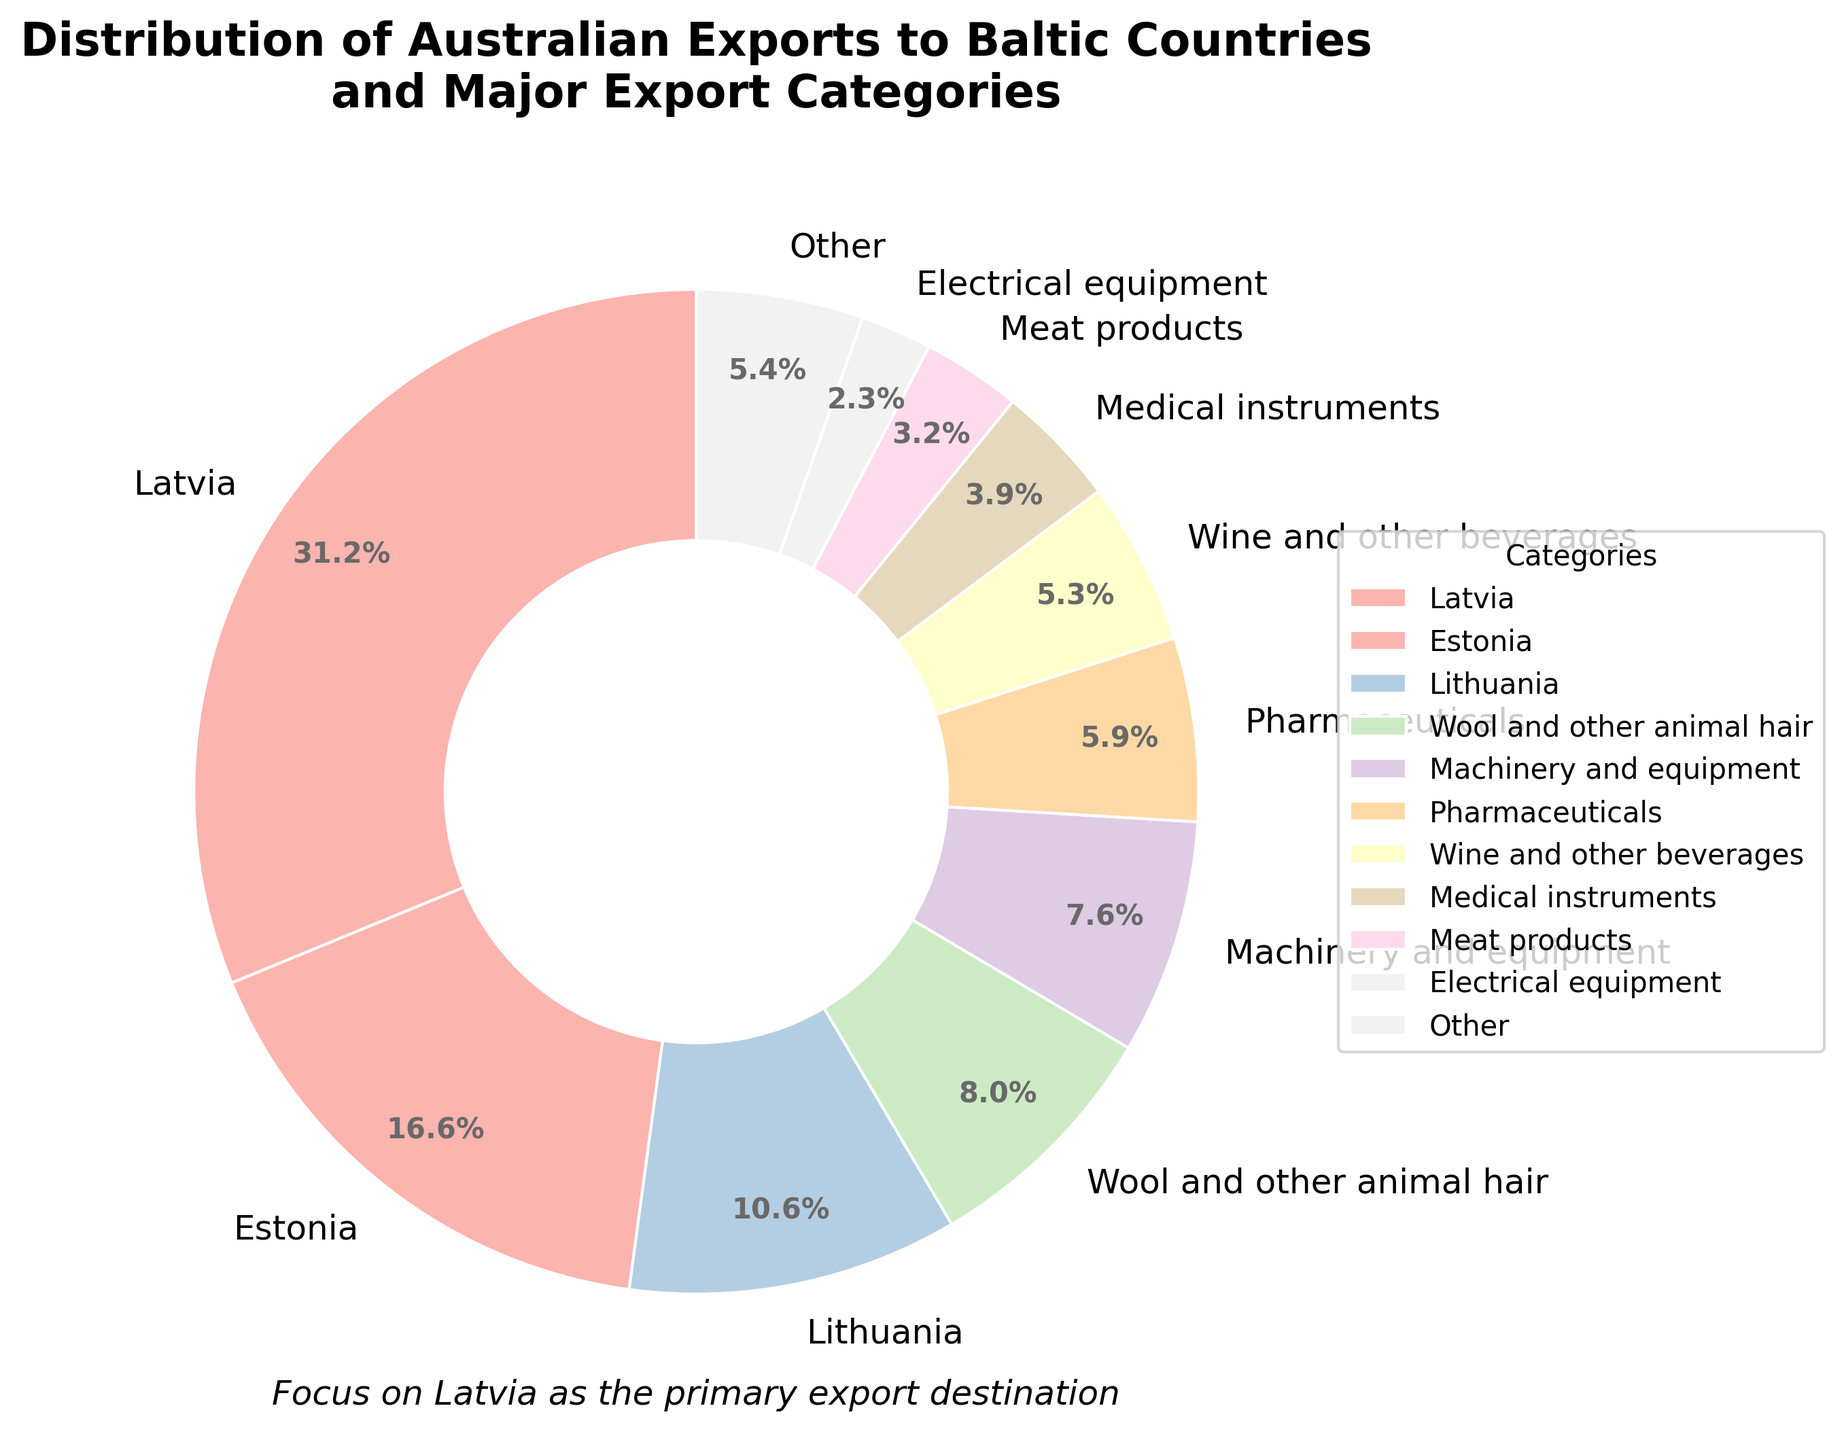What is the percentage of Australian exports to Latvia? Referring to the pie chart, find the label marked "Latvia" and look at the percentage value next to it.
Answer: 46.3% Which country receives the least amount of Australian exports among the Baltic countries? From the pie chart, identify and compare the percentage labels for Latvia, Estonia, and Lithuania. The one with the smallest percentage receives the least exports.
Answer: Lithuania What is the combined percentage of exports to Estonia and Lithuania? Locate the percentage labels for Estonia and Lithuania on the pie chart, then add these two percentages together (24.7% + 15.8%).
Answer: 40.5% How much greater is the export value to Latvia compared to Estonia? Refer to the export values in the pie chart: AUD 28.5 million for Latvia and AUD 15.2 million for Estonia. Subtract Estonia's export value from Latvia's (28.5 - 15.2).
Answer: AUD 13.3 million Identify which non-country category has the highest percentage and its value. Look at the non-country categories in the pie chart (Wool and other animal hair, Machinery and equipment, Pharmaceuticals, Wine and other beverages, Medical instruments) and identify the one with the largest percentage. In this case, "Wool and other animal hair."
Answer: Wool and other animal hair, 12.5% What percentage of the total exports is accounted for by the 'Other' category? Locate the segment labeled "Other" in the pie chart and read the corresponding percentage value.
Answer: 5.9% If the total export value is AUD 86.3 million, how much is the export value for Wine and other beverages? Identify the percentage for "Wine and other beverages" in the pie chart (8.2%). Multiply this percentage by the total export value (86.3 million * 8.2%).
Answer: AUD 4.8 million Compare the export values of Machinery and equipment and Pharmaceuticals. Which one is higher and by how much? Refer to the values in the pie chart: Machinery and equipment (6.9%) and Pharmaceuticals (5.4%). Subtract the smaller percentage from the larger percentage (6.9% - 5.4%).
Answer: Machinery and equipment is higher by 1.5% What is the combined percentage of the top three export categories to Baltic countries? Identify the top three categories in the pie chart (Latvia, Estonia, Lithuania) and add their percentages together (46.3% + 17.6% + 13.1%).
Answer: 77% What is the color used to represent Latvia in the pie chart, and how does it compare to the colors of Estonia and Lithuania? Identify the segment for Latvia and note its color. Compare this to the colors for Estonia and Lithuania.
Answer: Latvia: light pink, Estonia: light blue, Lithuania: light green 